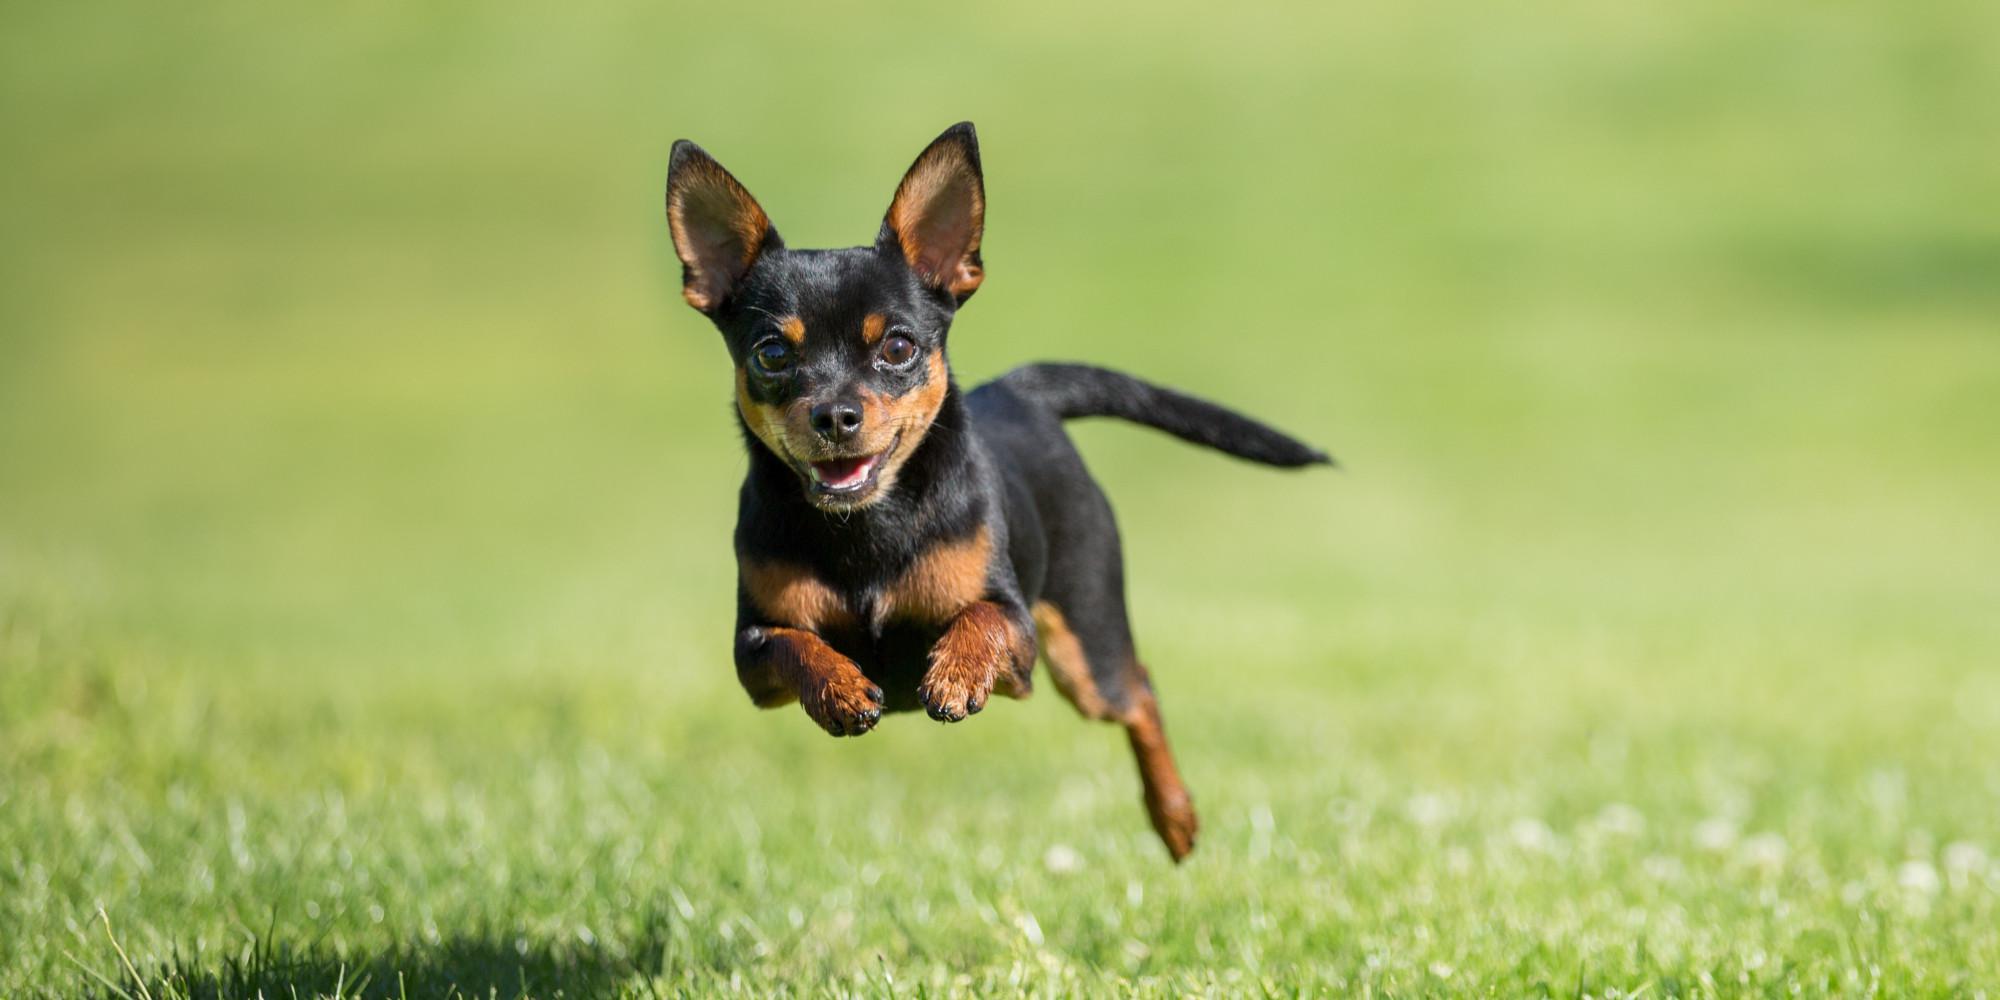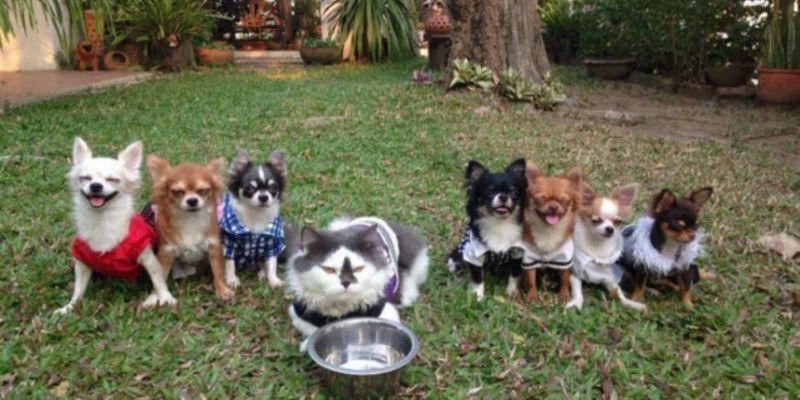The first image is the image on the left, the second image is the image on the right. Analyze the images presented: Is the assertion "There is no more than one chihuahua in the right image." valid? Answer yes or no. No. The first image is the image on the left, the second image is the image on the right. For the images displayed, is the sentence "An image shows one dog, which is in a grassy area." factually correct? Answer yes or no. Yes. 